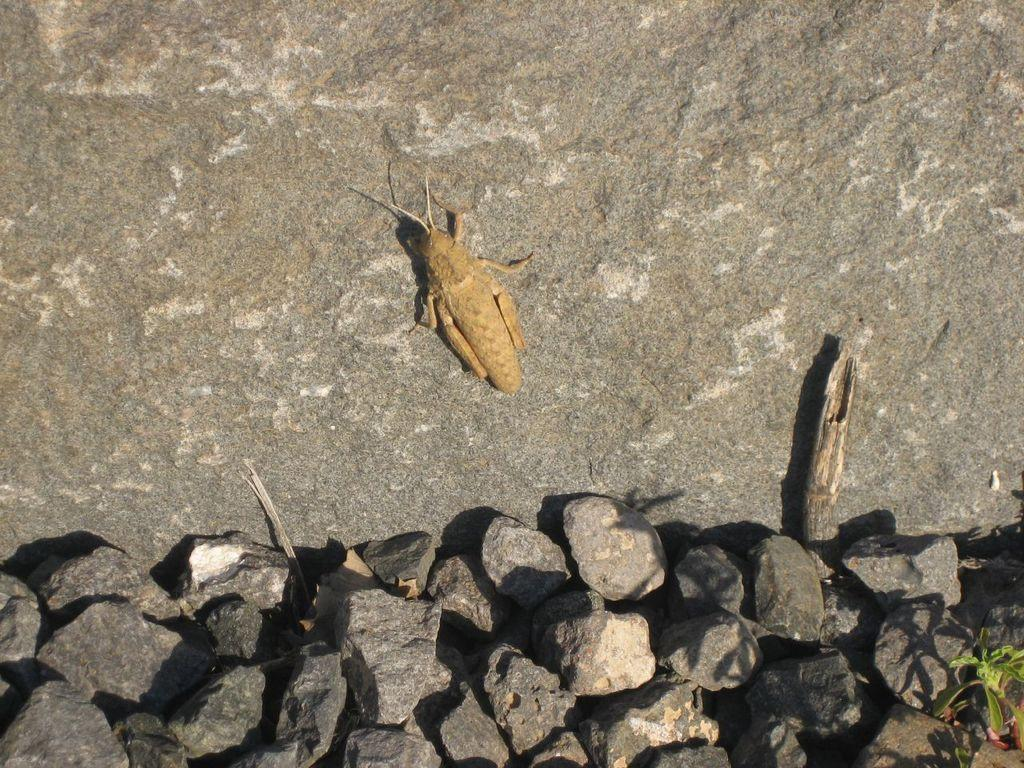What is the main subject of the image? There is an insect on a rock in the image. What else can be seen at the bottom of the image? There is a group of stones at the bottom of the image. Is there any vegetation present in the image? Yes, there is a plant in the bottom right of the image. What type of shirt is the insect wearing in the image? Insects do not wear shirts, so this question cannot be answered. 